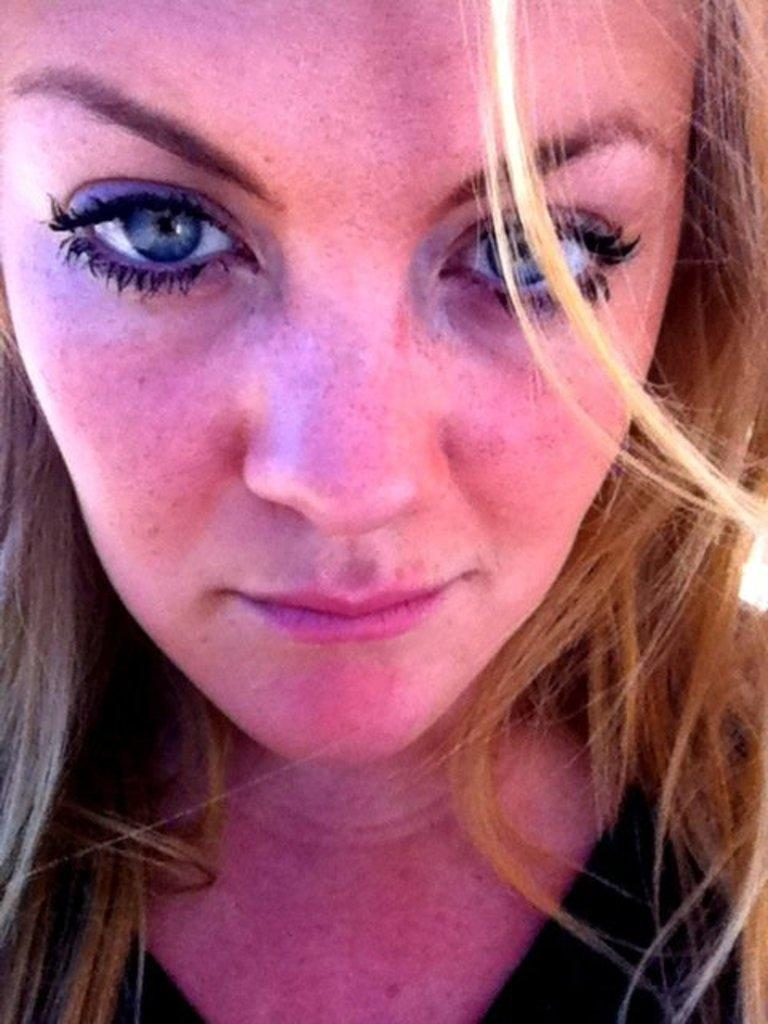Who is present in the image? There is a woman in the image. How many legs does the beast have in the image? There is no beast present in the image, so it is not possible to determine the number of legs it might have. 